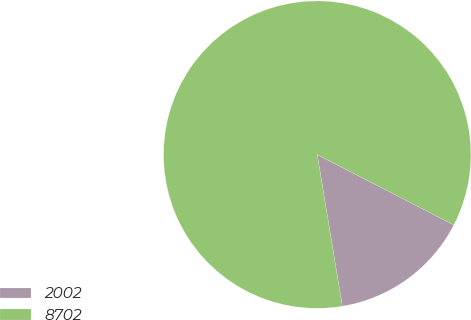<chart> <loc_0><loc_0><loc_500><loc_500><pie_chart><fcel>2002<fcel>8702<nl><fcel>14.82%<fcel>85.18%<nl></chart> 